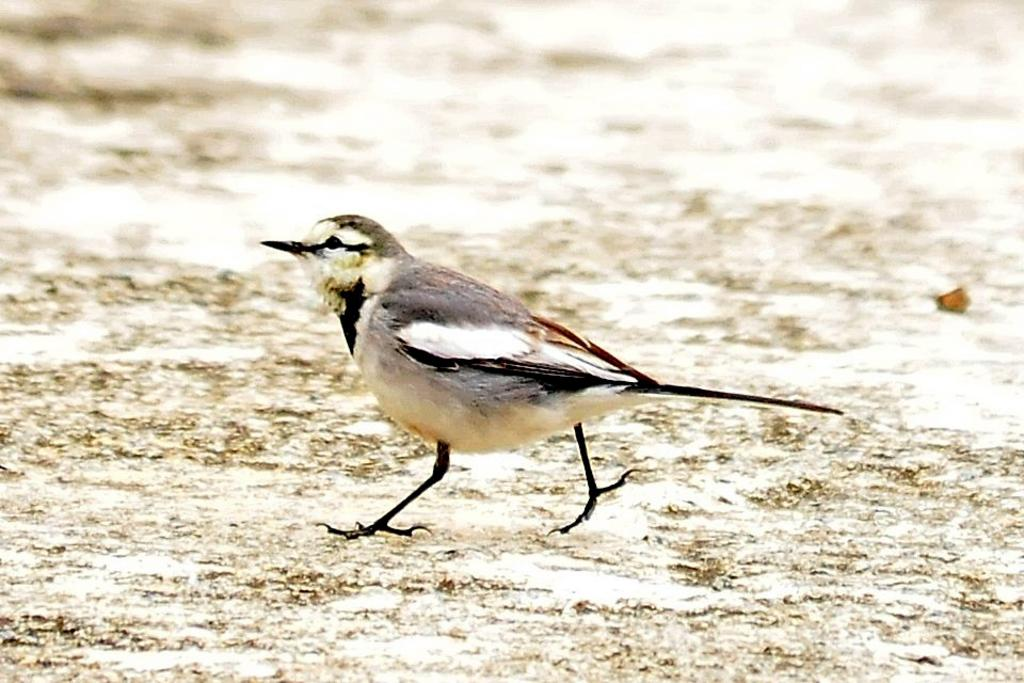What type of animal can be seen in the image? There is a bird in the image. What is the bird doing in the image? The bird is walking on land in the image. What colors are present on the bird? The bird has a black and white color. Can you tell me what type of doctor the bird is consulting in the image? There is no doctor present in the image, as it features a bird walking on land with a black and white color. 